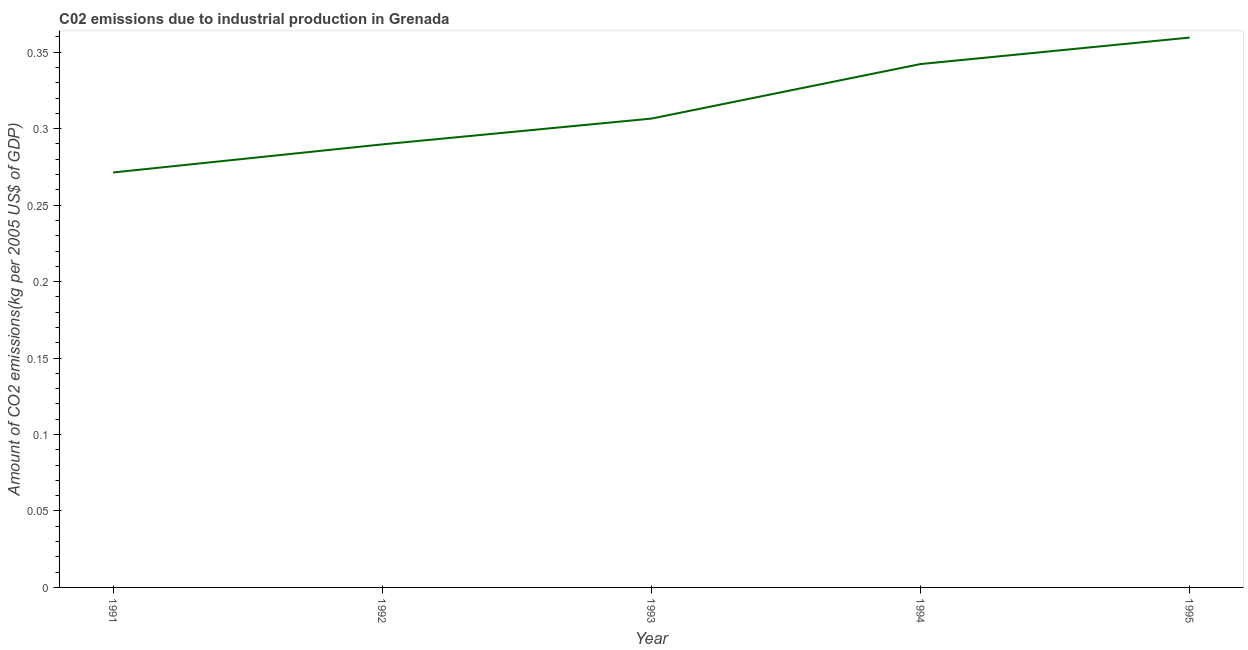What is the amount of co2 emissions in 1993?
Your response must be concise. 0.31. Across all years, what is the maximum amount of co2 emissions?
Provide a succinct answer. 0.36. Across all years, what is the minimum amount of co2 emissions?
Your answer should be very brief. 0.27. What is the sum of the amount of co2 emissions?
Give a very brief answer. 1.57. What is the difference between the amount of co2 emissions in 1992 and 1995?
Give a very brief answer. -0.07. What is the average amount of co2 emissions per year?
Provide a short and direct response. 0.31. What is the median amount of co2 emissions?
Offer a terse response. 0.31. In how many years, is the amount of co2 emissions greater than 0.01 kg per 2005 US$ of GDP?
Ensure brevity in your answer.  5. Do a majority of the years between 1995 and 1993 (inclusive) have amount of co2 emissions greater than 0.28 kg per 2005 US$ of GDP?
Make the answer very short. No. What is the ratio of the amount of co2 emissions in 1991 to that in 1993?
Your answer should be very brief. 0.89. What is the difference between the highest and the second highest amount of co2 emissions?
Your answer should be compact. 0.02. What is the difference between the highest and the lowest amount of co2 emissions?
Your answer should be very brief. 0.09. How many lines are there?
Keep it short and to the point. 1. What is the difference between two consecutive major ticks on the Y-axis?
Ensure brevity in your answer.  0.05. What is the title of the graph?
Your answer should be very brief. C02 emissions due to industrial production in Grenada. What is the label or title of the X-axis?
Your response must be concise. Year. What is the label or title of the Y-axis?
Offer a very short reply. Amount of CO2 emissions(kg per 2005 US$ of GDP). What is the Amount of CO2 emissions(kg per 2005 US$ of GDP) in 1991?
Give a very brief answer. 0.27. What is the Amount of CO2 emissions(kg per 2005 US$ of GDP) of 1992?
Make the answer very short. 0.29. What is the Amount of CO2 emissions(kg per 2005 US$ of GDP) in 1993?
Offer a very short reply. 0.31. What is the Amount of CO2 emissions(kg per 2005 US$ of GDP) of 1994?
Offer a terse response. 0.34. What is the Amount of CO2 emissions(kg per 2005 US$ of GDP) in 1995?
Offer a terse response. 0.36. What is the difference between the Amount of CO2 emissions(kg per 2005 US$ of GDP) in 1991 and 1992?
Your response must be concise. -0.02. What is the difference between the Amount of CO2 emissions(kg per 2005 US$ of GDP) in 1991 and 1993?
Give a very brief answer. -0.04. What is the difference between the Amount of CO2 emissions(kg per 2005 US$ of GDP) in 1991 and 1994?
Keep it short and to the point. -0.07. What is the difference between the Amount of CO2 emissions(kg per 2005 US$ of GDP) in 1991 and 1995?
Ensure brevity in your answer.  -0.09. What is the difference between the Amount of CO2 emissions(kg per 2005 US$ of GDP) in 1992 and 1993?
Keep it short and to the point. -0.02. What is the difference between the Amount of CO2 emissions(kg per 2005 US$ of GDP) in 1992 and 1994?
Offer a very short reply. -0.05. What is the difference between the Amount of CO2 emissions(kg per 2005 US$ of GDP) in 1992 and 1995?
Offer a terse response. -0.07. What is the difference between the Amount of CO2 emissions(kg per 2005 US$ of GDP) in 1993 and 1994?
Keep it short and to the point. -0.04. What is the difference between the Amount of CO2 emissions(kg per 2005 US$ of GDP) in 1993 and 1995?
Ensure brevity in your answer.  -0.05. What is the difference between the Amount of CO2 emissions(kg per 2005 US$ of GDP) in 1994 and 1995?
Keep it short and to the point. -0.02. What is the ratio of the Amount of CO2 emissions(kg per 2005 US$ of GDP) in 1991 to that in 1992?
Keep it short and to the point. 0.94. What is the ratio of the Amount of CO2 emissions(kg per 2005 US$ of GDP) in 1991 to that in 1993?
Give a very brief answer. 0.89. What is the ratio of the Amount of CO2 emissions(kg per 2005 US$ of GDP) in 1991 to that in 1994?
Offer a very short reply. 0.79. What is the ratio of the Amount of CO2 emissions(kg per 2005 US$ of GDP) in 1991 to that in 1995?
Your answer should be very brief. 0.76. What is the ratio of the Amount of CO2 emissions(kg per 2005 US$ of GDP) in 1992 to that in 1993?
Your answer should be very brief. 0.94. What is the ratio of the Amount of CO2 emissions(kg per 2005 US$ of GDP) in 1992 to that in 1994?
Your answer should be very brief. 0.85. What is the ratio of the Amount of CO2 emissions(kg per 2005 US$ of GDP) in 1992 to that in 1995?
Your answer should be compact. 0.81. What is the ratio of the Amount of CO2 emissions(kg per 2005 US$ of GDP) in 1993 to that in 1994?
Your response must be concise. 0.9. What is the ratio of the Amount of CO2 emissions(kg per 2005 US$ of GDP) in 1993 to that in 1995?
Make the answer very short. 0.85. What is the ratio of the Amount of CO2 emissions(kg per 2005 US$ of GDP) in 1994 to that in 1995?
Give a very brief answer. 0.95. 